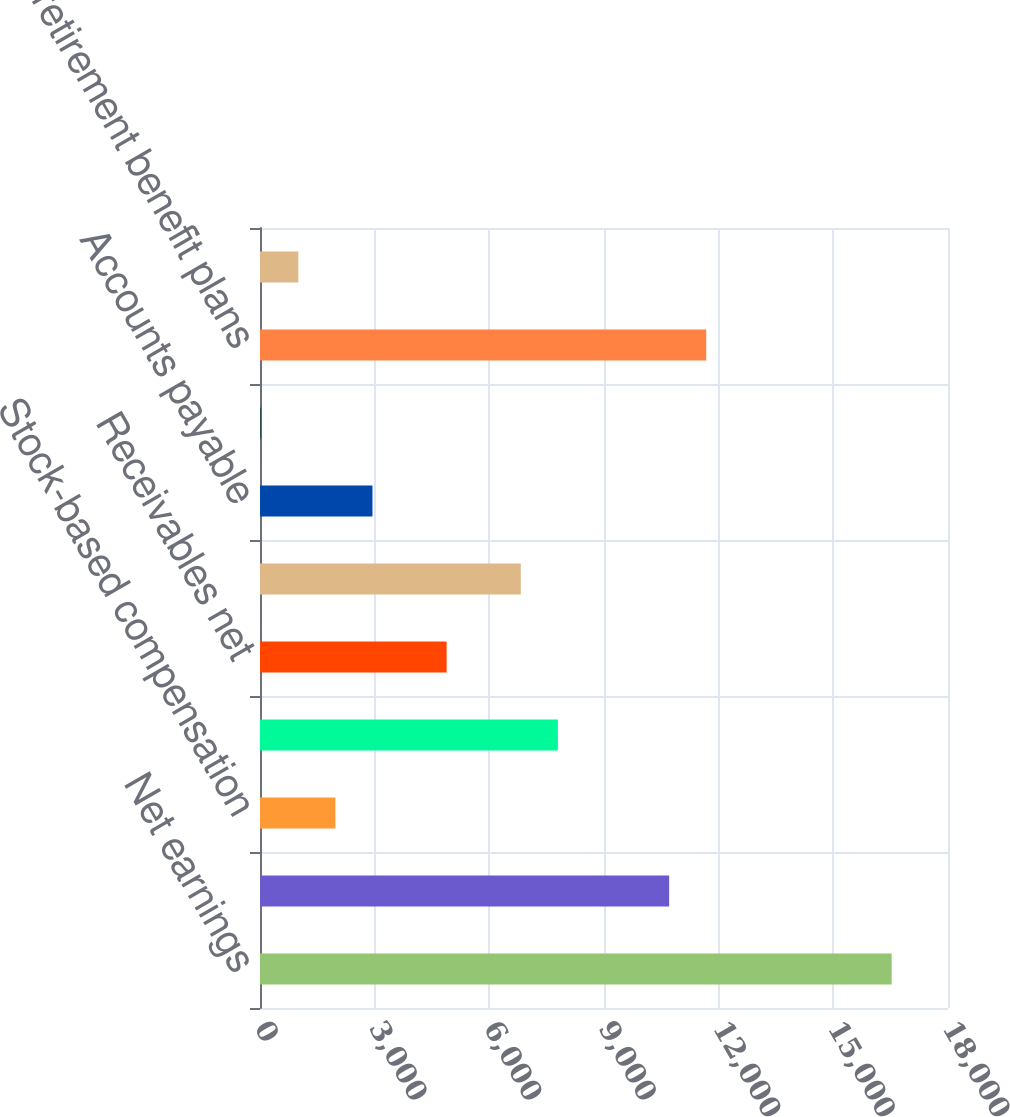Convert chart. <chart><loc_0><loc_0><loc_500><loc_500><bar_chart><fcel>Net earnings<fcel>Depreciation and amortization<fcel>Stock-based compensation<fcel>Deferred income taxes<fcel>Receivables net<fcel>Inventories net<fcel>Accounts payable<fcel>Customer advances and amounts<fcel>Postretirement benefit plans<fcel>Income taxes<nl><fcel>16525.4<fcel>10704.2<fcel>1972.4<fcel>7793.6<fcel>4883<fcel>6823.4<fcel>2942.6<fcel>32<fcel>11674.4<fcel>1002.2<nl></chart> 